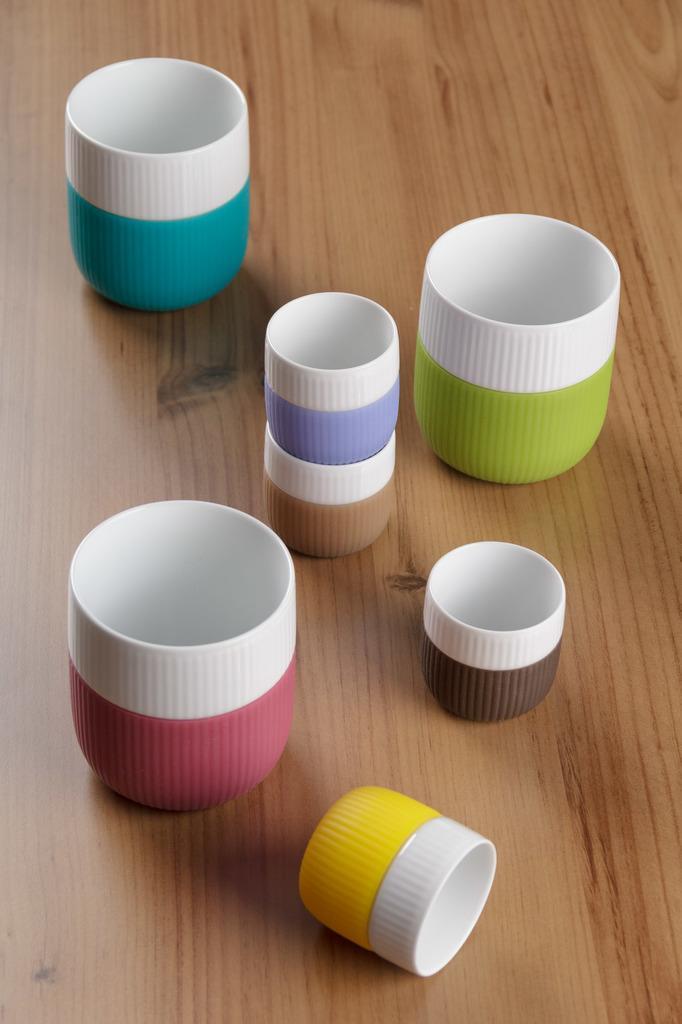In one or two sentences, can you explain what this image depicts? In this image I can see there are plastic things on a wooden board. 